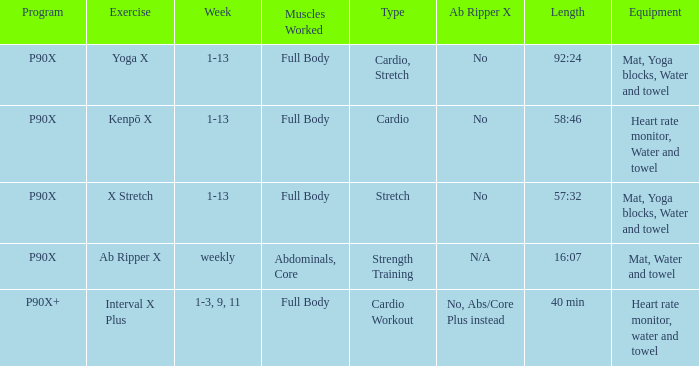During which week is the cardio workout type scheduled? 1-3, 9, 11. 